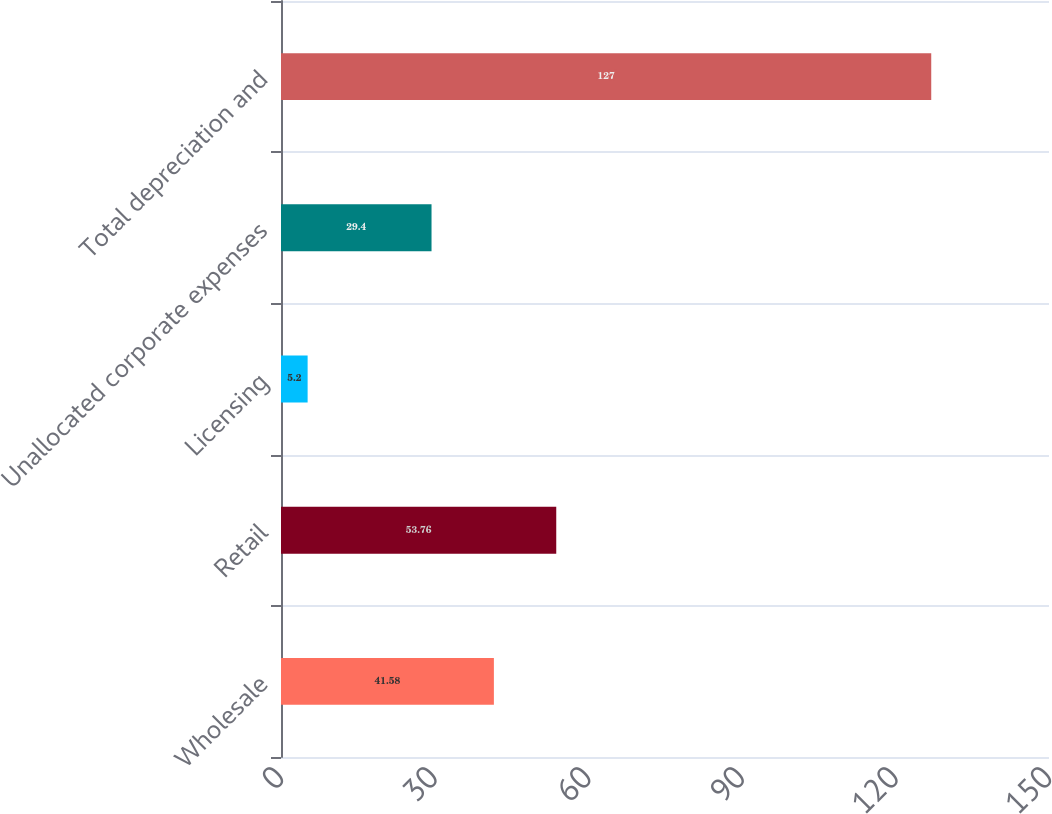Convert chart. <chart><loc_0><loc_0><loc_500><loc_500><bar_chart><fcel>Wholesale<fcel>Retail<fcel>Licensing<fcel>Unallocated corporate expenses<fcel>Total depreciation and<nl><fcel>41.58<fcel>53.76<fcel>5.2<fcel>29.4<fcel>127<nl></chart> 